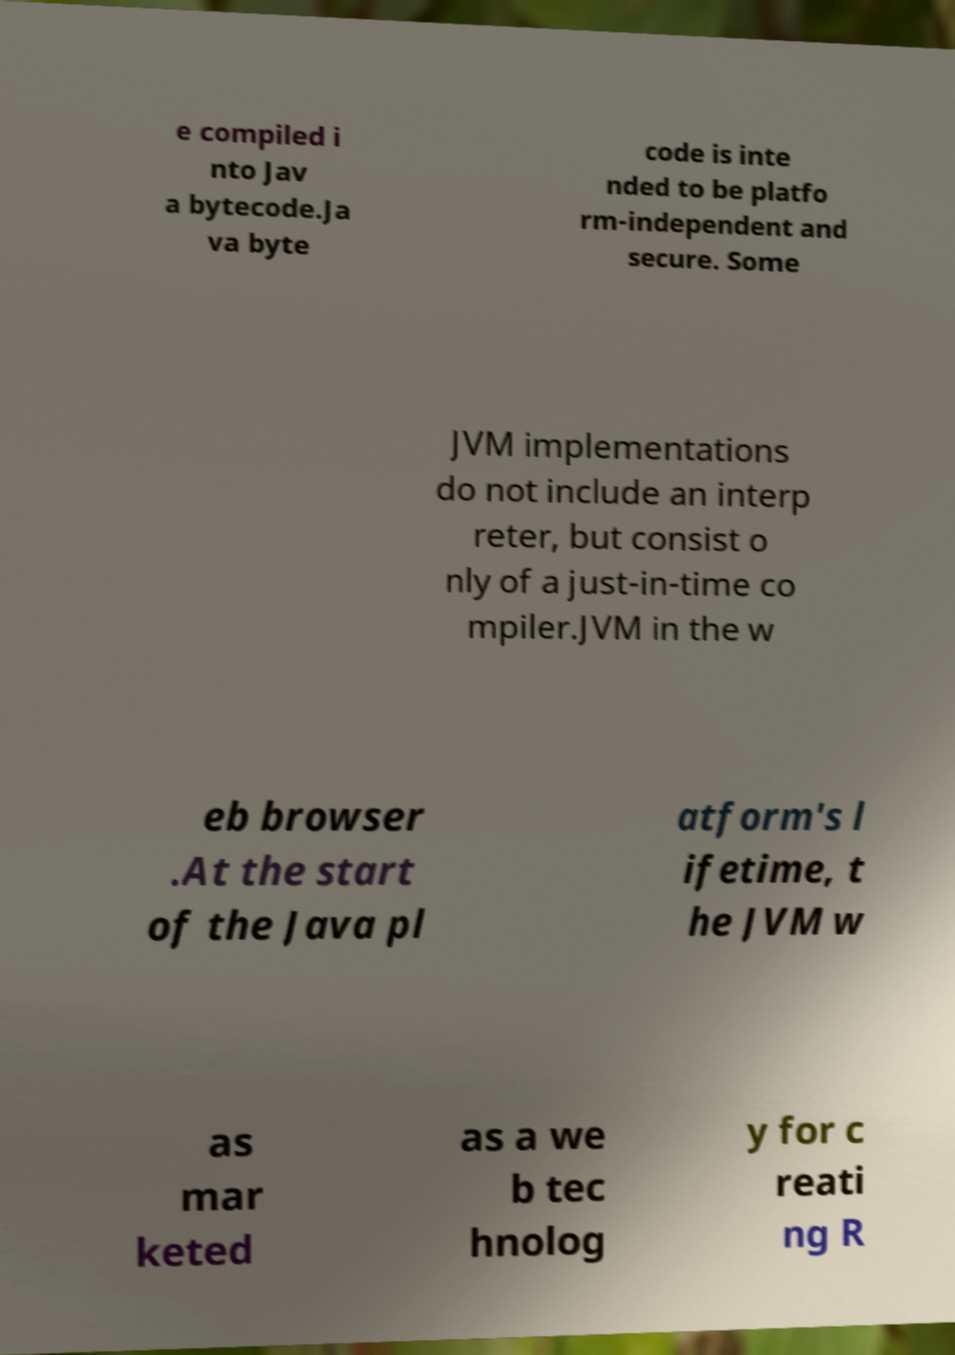Can you accurately transcribe the text from the provided image for me? e compiled i nto Jav a bytecode.Ja va byte code is inte nded to be platfo rm-independent and secure. Some JVM implementations do not include an interp reter, but consist o nly of a just-in-time co mpiler.JVM in the w eb browser .At the start of the Java pl atform's l ifetime, t he JVM w as mar keted as a we b tec hnolog y for c reati ng R 